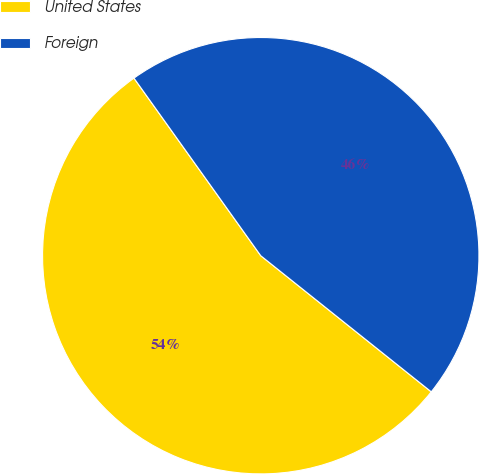Convert chart to OTSL. <chart><loc_0><loc_0><loc_500><loc_500><pie_chart><fcel>United States<fcel>Foreign<nl><fcel>54.41%<fcel>45.59%<nl></chart> 